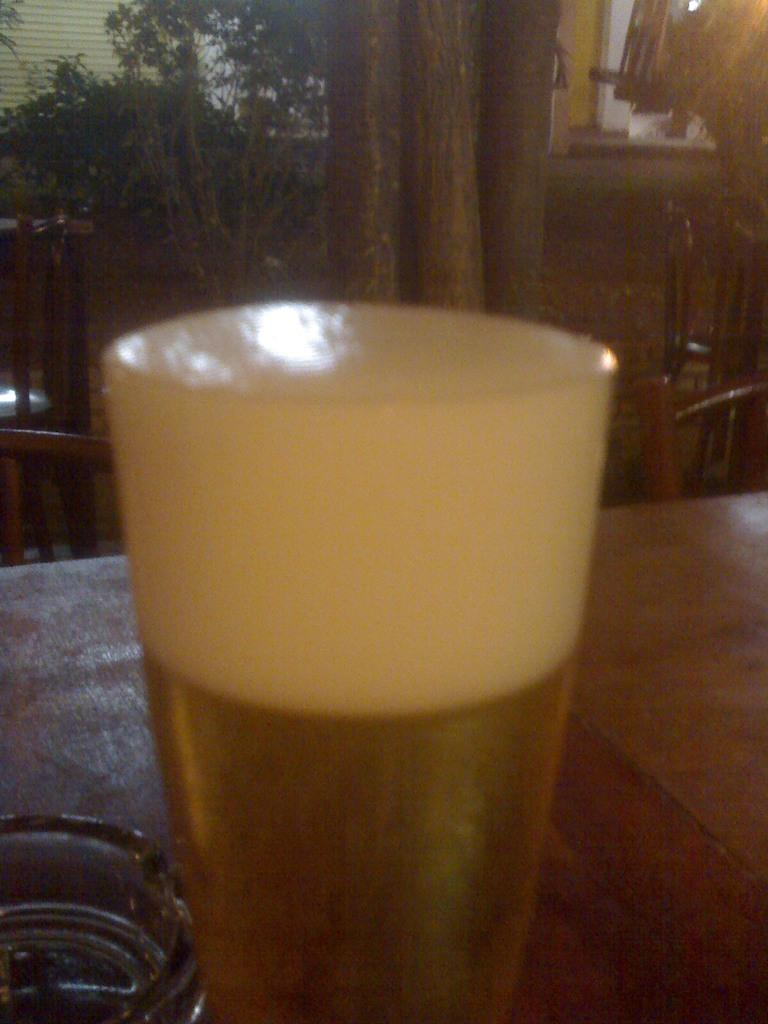What is in the glass that is visible in the image? There is a glass with wine in it. Where is the glass located in the image? The glass is on a platform. What can be seen in the background of the image? There are trees, plants, chairs, a wall, and other objects visible in the background of the image. How many beads are present in the image? There are no beads visible in the image. What is the belief system of the person who owns the glass with wine? The image does not provide any information about the belief system of the person who owns the glass with wine. 